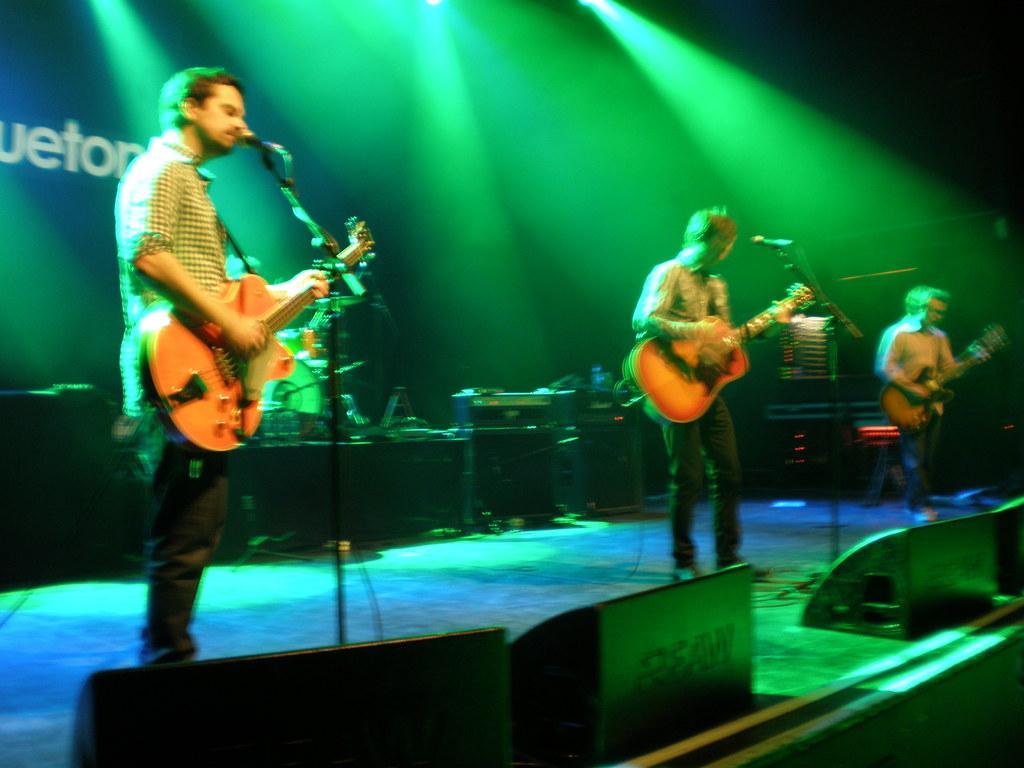In one or two sentences, can you explain what this image depicts? In this image there are three persons who are standing. On the left side there is one person who is standing and he is holding a guitar, in front of him there is one mike. In the middle of the image there is another person who is standing and he is holding a guitar in front of him there is another mike. On the right side there is one man who is standing and he is holding a guitar and on the background we can see some disco lights and wall and one stage is there. 